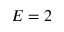Convert formula to latex. <formula><loc_0><loc_0><loc_500><loc_500>E = 2</formula> 